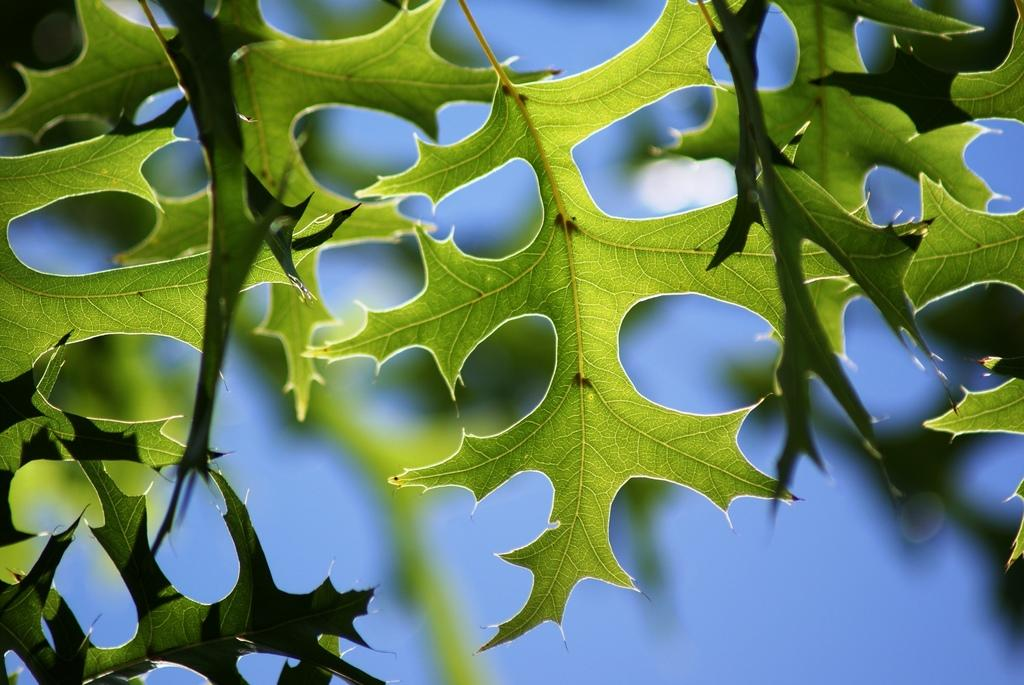What type of vegetation is visible in the image? There are leaves of a tree in the image. Can you describe the leaves in the image? The leaves appear to be green and are likely from a deciduous tree. What might be the purpose of the leaves in the image? The leaves are likely part of a tree that provides shade, oxygen, and habitat for various organisms. How does the tree in the image help people believe in miracles? The image does not depict any miracles or beliefs; it simply shows leaves of a tree. 